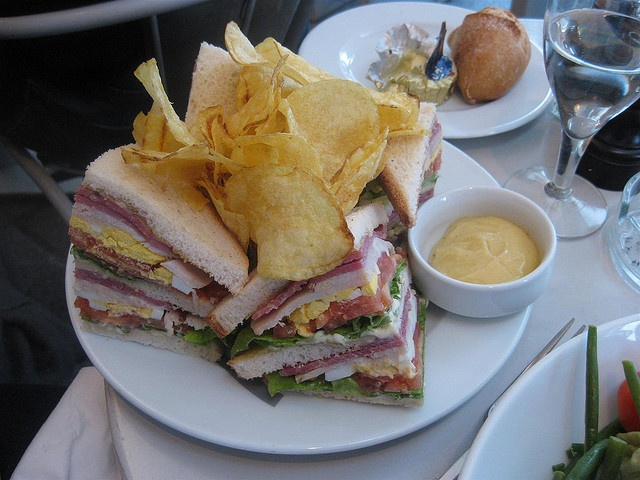Describe the objects in this image and their specific colors. I can see dining table in black, darkgray, and gray tones, sandwich in black, gray, and darkgray tones, sandwich in black, gray, darkgray, and maroon tones, wine glass in black, gray, and darkgray tones, and bowl in black, tan, darkgray, and gray tones in this image. 